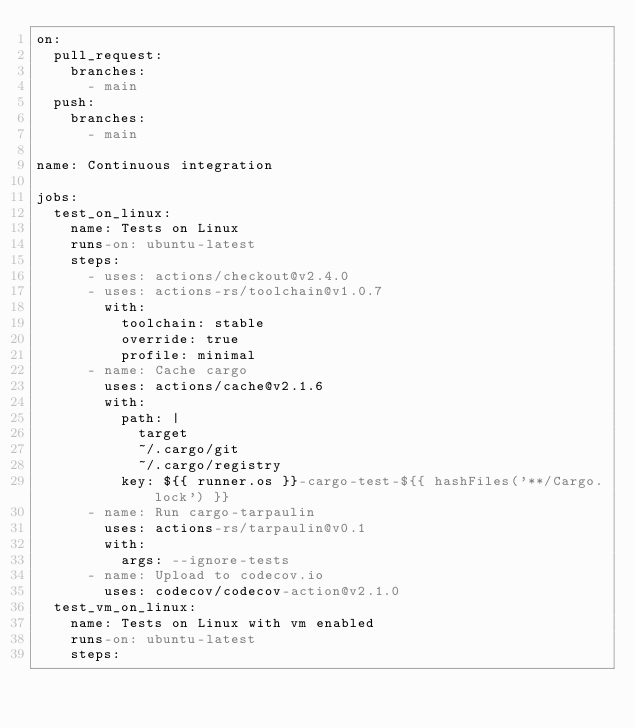Convert code to text. <code><loc_0><loc_0><loc_500><loc_500><_YAML_>on:
  pull_request:
    branches:
      - main
  push:
    branches:
      - main

name: Continuous integration

jobs:
  test_on_linux:
    name: Tests on Linux
    runs-on: ubuntu-latest
    steps:
      - uses: actions/checkout@v2.4.0
      - uses: actions-rs/toolchain@v1.0.7
        with:
          toolchain: stable
          override: true
          profile: minimal
      - name: Cache cargo
        uses: actions/cache@v2.1.6
        with:
          path: |
            target
            ~/.cargo/git
            ~/.cargo/registry
          key: ${{ runner.os }}-cargo-test-${{ hashFiles('**/Cargo.lock') }}
      - name: Run cargo-tarpaulin
        uses: actions-rs/tarpaulin@v0.1
        with:
          args: --ignore-tests
      - name: Upload to codecov.io
        uses: codecov/codecov-action@v2.1.0
  test_vm_on_linux:
    name: Tests on Linux with vm enabled
    runs-on: ubuntu-latest
    steps:</code> 